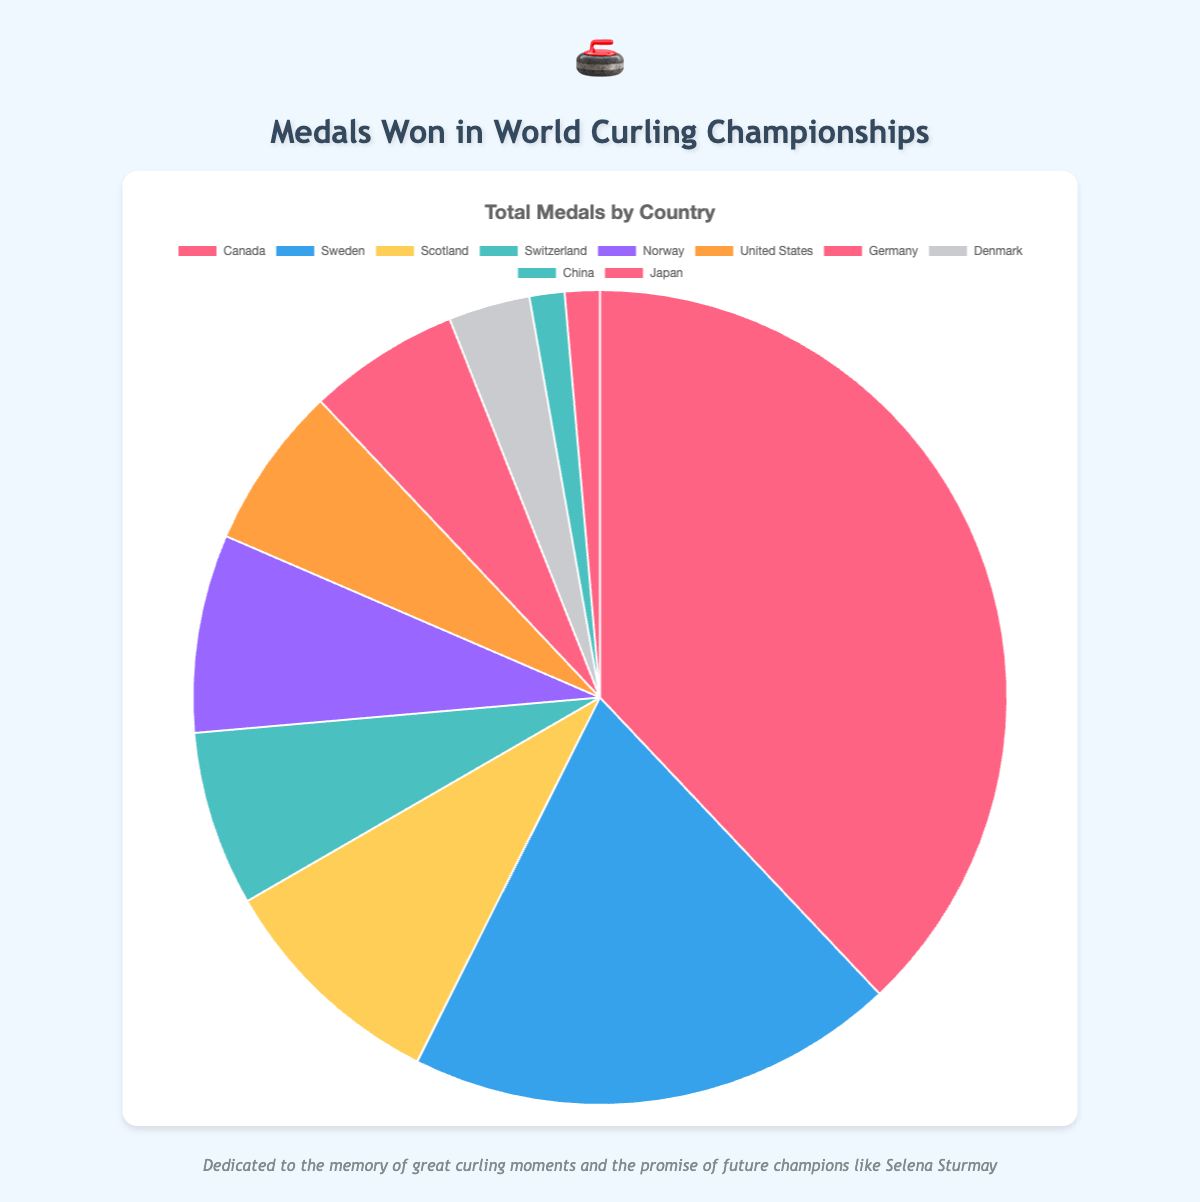Which country has won the most medals in total? By adding the number of gold, silver, and bronze medals for each country, Canada has a total of 82 medals (36 gold + 26 silver + 20 bronze), which is the highest.
Answer: Canada How many more medals has Canada won compared to Sweden? Canada has won 82 medals in total, while Sweden has won 42 medals. The difference is 82 - 42 = 40 medals.
Answer: 40 What is the combined total of bronze medals won by Scotland and Switzerland? Scotland has won 9 bronze medals and Switzerland has won 8 bronze medals. Combined, they have 9 + 8 = 17 bronze medals.
Answer: 17 What percentage of the total medals were won by the United States? The total number of medals for all countries is 82 (Canada) + 42 (Sweden) + 20 (Scotland) + 15 (Switzerland) + 17 (Norway) + 14 (United States) + 13 (Germany) + 7 (Denmark) + 3 (China) + 3 (Japan) = 216 medals. The United States has won 14 medals. The percentage is (14 / 216) * 100 ≈ 6.48%.
Answer: 6.48% Which countries share the same number of total medals won, and what is that number? By looking at the data, both China and Japan have won 3 medals each in total.
Answer: China and Japan, 3 medals What is the color used to represent Norway in the pie chart? In the pie chart, Norway is represented by the color purple.
Answer: Purple Compare the total medals won by Germany and Denmark. Which country has won more medals and by how much? Germany has won 13 medals in total, whereas Denmark has won 7 medals. Germany has won 13 - 7 = 6 more medals than Denmark.
Answer: Germany, 6 What is the ratio of gold medals to the total medals for Switzerland? Switzerland has 3 gold medals and a total of 15 medals. The ratio is 3 / 15 = 1 / 5 or 20%.
Answer: 1:5 or 20% How many countries have won 10 or more total medals? The countries with 10 or more total medals are Canada (82), Sweden (42), Scotland (20), Switzerland (15), Norway (17), United States (14), and Germany (13). There are 7 such countries.
Answer: 7 What is the sum of silver medals won by Sweden and Norway? Sweden has 19 silver medals and Norway has 7 silver medals. The sum is 19 + 7 = 26 silver medals.
Answer: 26 